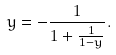Convert formula to latex. <formula><loc_0><loc_0><loc_500><loc_500>y = - \frac { 1 } { 1 + \frac { 1 } { 1 - y } } .</formula> 